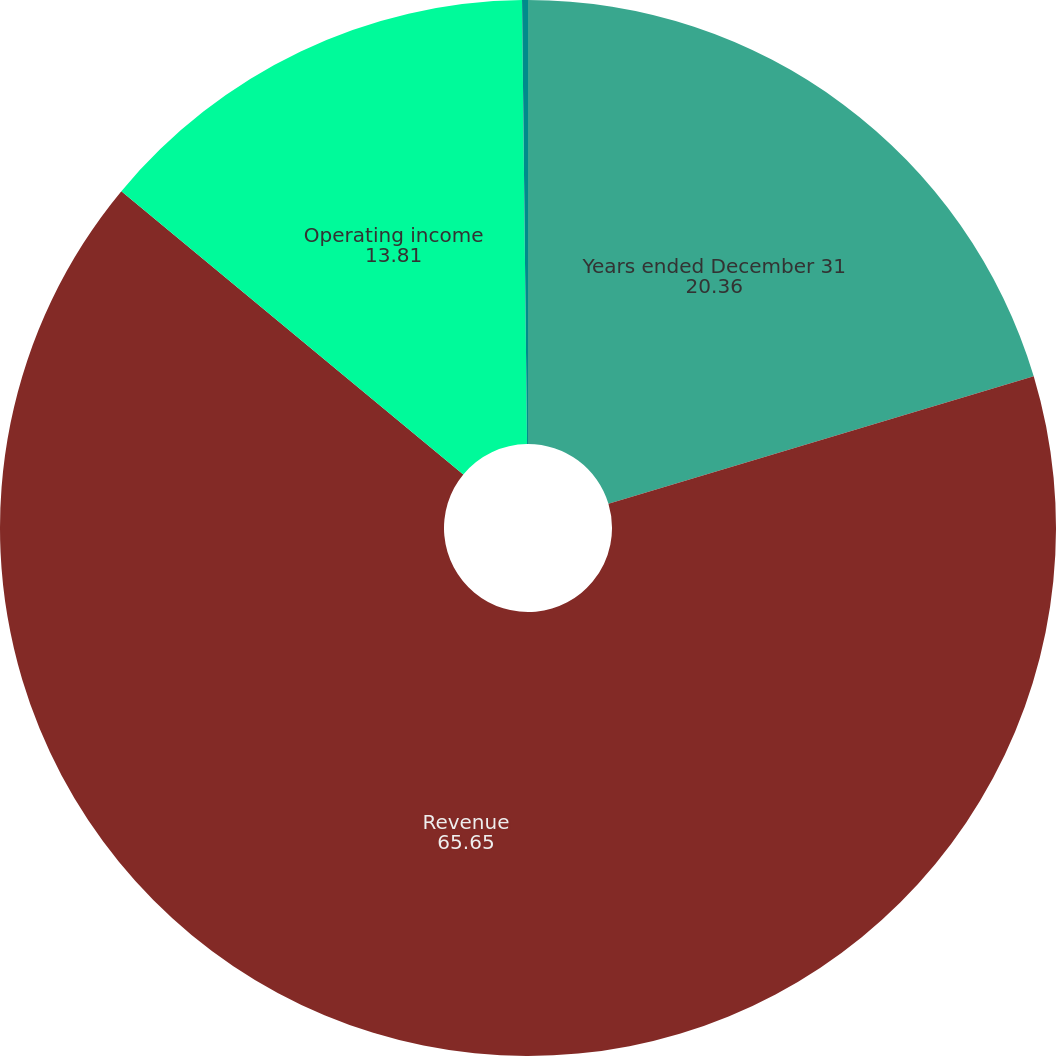<chart> <loc_0><loc_0><loc_500><loc_500><pie_chart><fcel>Years ended December 31<fcel>Revenue<fcel>Operating income<fcel>Operating margin<nl><fcel>20.36%<fcel>65.65%<fcel>13.81%<fcel>0.18%<nl></chart> 